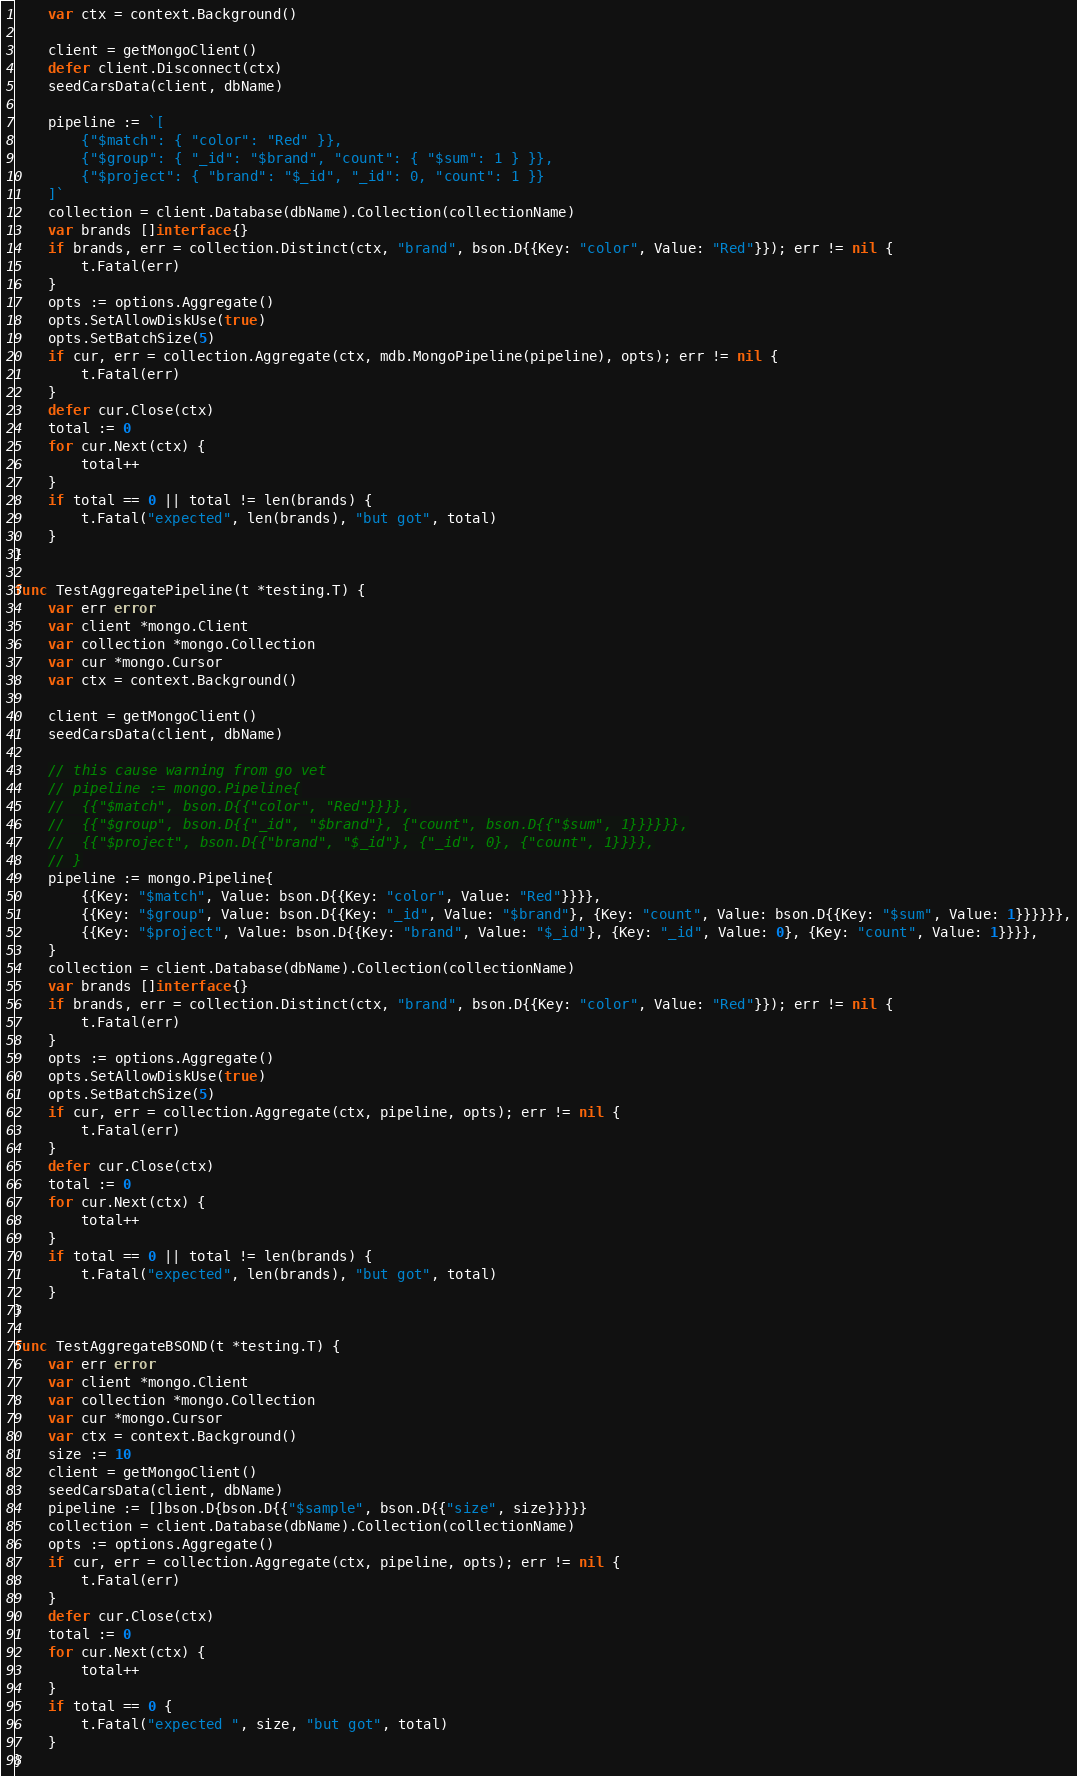Convert code to text. <code><loc_0><loc_0><loc_500><loc_500><_Go_>	var ctx = context.Background()

	client = getMongoClient()
	defer client.Disconnect(ctx)
	seedCarsData(client, dbName)

	pipeline := `[
		{"$match": { "color": "Red" }},
		{"$group": { "_id": "$brand", "count": { "$sum": 1 } }},
		{"$project": { "brand": "$_id", "_id": 0, "count": 1 }}
	]`
	collection = client.Database(dbName).Collection(collectionName)
	var brands []interface{}
	if brands, err = collection.Distinct(ctx, "brand", bson.D{{Key: "color", Value: "Red"}}); err != nil {
		t.Fatal(err)
	}
	opts := options.Aggregate()
	opts.SetAllowDiskUse(true)
	opts.SetBatchSize(5)
	if cur, err = collection.Aggregate(ctx, mdb.MongoPipeline(pipeline), opts); err != nil {
		t.Fatal(err)
	}
	defer cur.Close(ctx)
	total := 0
	for cur.Next(ctx) {
		total++
	}
	if total == 0 || total != len(brands) {
		t.Fatal("expected", len(brands), "but got", total)
	}
}

func TestAggregatePipeline(t *testing.T) {
	var err error
	var client *mongo.Client
	var collection *mongo.Collection
	var cur *mongo.Cursor
	var ctx = context.Background()

	client = getMongoClient()
	seedCarsData(client, dbName)

	// this cause warning from go vet
	// pipeline := mongo.Pipeline{
	// 	{{"$match", bson.D{{"color", "Red"}}}},
	// 	{{"$group", bson.D{{"_id", "$brand"}, {"count", bson.D{{"$sum", 1}}}}}},
	// 	{{"$project", bson.D{{"brand", "$_id"}, {"_id", 0}, {"count", 1}}}},
	// }
	pipeline := mongo.Pipeline{
		{{Key: "$match", Value: bson.D{{Key: "color", Value: "Red"}}}},
		{{Key: "$group", Value: bson.D{{Key: "_id", Value: "$brand"}, {Key: "count", Value: bson.D{{Key: "$sum", Value: 1}}}}}},
		{{Key: "$project", Value: bson.D{{Key: "brand", Value: "$_id"}, {Key: "_id", Value: 0}, {Key: "count", Value: 1}}}},
	}
	collection = client.Database(dbName).Collection(collectionName)
	var brands []interface{}
	if brands, err = collection.Distinct(ctx, "brand", bson.D{{Key: "color", Value: "Red"}}); err != nil {
		t.Fatal(err)
	}
	opts := options.Aggregate()
	opts.SetAllowDiskUse(true)
	opts.SetBatchSize(5)
	if cur, err = collection.Aggregate(ctx, pipeline, opts); err != nil {
		t.Fatal(err)
	}
	defer cur.Close(ctx)
	total := 0
	for cur.Next(ctx) {
		total++
	}
	if total == 0 || total != len(brands) {
		t.Fatal("expected", len(brands), "but got", total)
	}
}

func TestAggregateBSOND(t *testing.T) {
	var err error
	var client *mongo.Client
	var collection *mongo.Collection
	var cur *mongo.Cursor
	var ctx = context.Background()
	size := 10
	client = getMongoClient()
	seedCarsData(client, dbName)
	pipeline := []bson.D{bson.D{{"$sample", bson.D{{"size", size}}}}}
	collection = client.Database(dbName).Collection(collectionName)
	opts := options.Aggregate()
	if cur, err = collection.Aggregate(ctx, pipeline, opts); err != nil {
		t.Fatal(err)
	}
	defer cur.Close(ctx)
	total := 0
	for cur.Next(ctx) {
		total++
	}
	if total == 0 {
		t.Fatal("expected ", size, "but got", total)
	}
}
</code> 